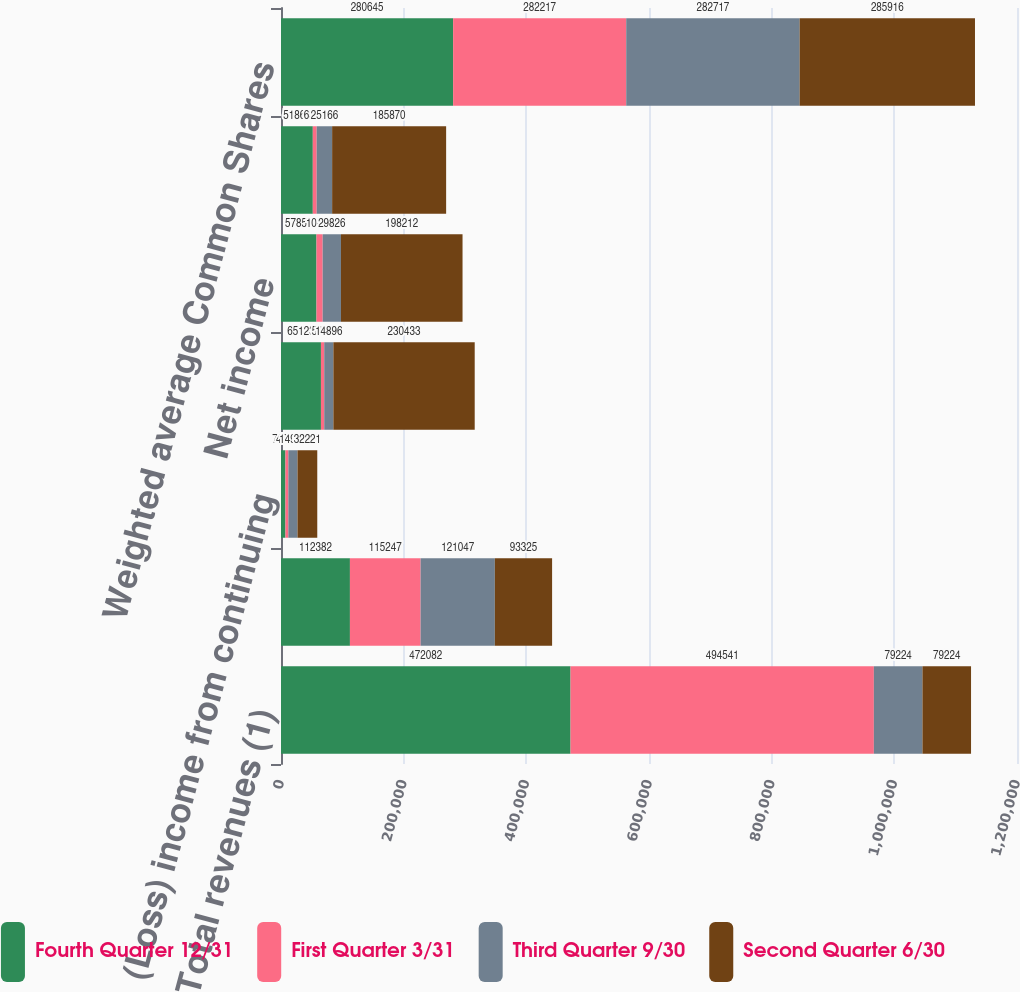Convert chart. <chart><loc_0><loc_0><loc_500><loc_500><stacked_bar_chart><ecel><fcel>Total revenues (1)<fcel>Operating income (1)<fcel>(Loss) income from continuing<fcel>Discontinued operations net<fcel>Net income<fcel>Net income available to Common<fcel>Weighted average Common Shares<nl><fcel>Fourth Quarter 12/31<fcel>472082<fcel>112382<fcel>7267<fcel>65123<fcel>57856<fcel>51863<fcel>280645<nl><fcel>First Quarter 3/31<fcel>494541<fcel>115247<fcel>4714<fcel>5375<fcel>10089<fcel>6343<fcel>282217<nl><fcel>Third Quarter 9/30<fcel>79224<fcel>121047<fcel>14930<fcel>14896<fcel>29826<fcel>25166<fcel>282717<nl><fcel>Second Quarter 6/30<fcel>79224<fcel>93325<fcel>32221<fcel>230433<fcel>198212<fcel>185870<fcel>285916<nl></chart> 